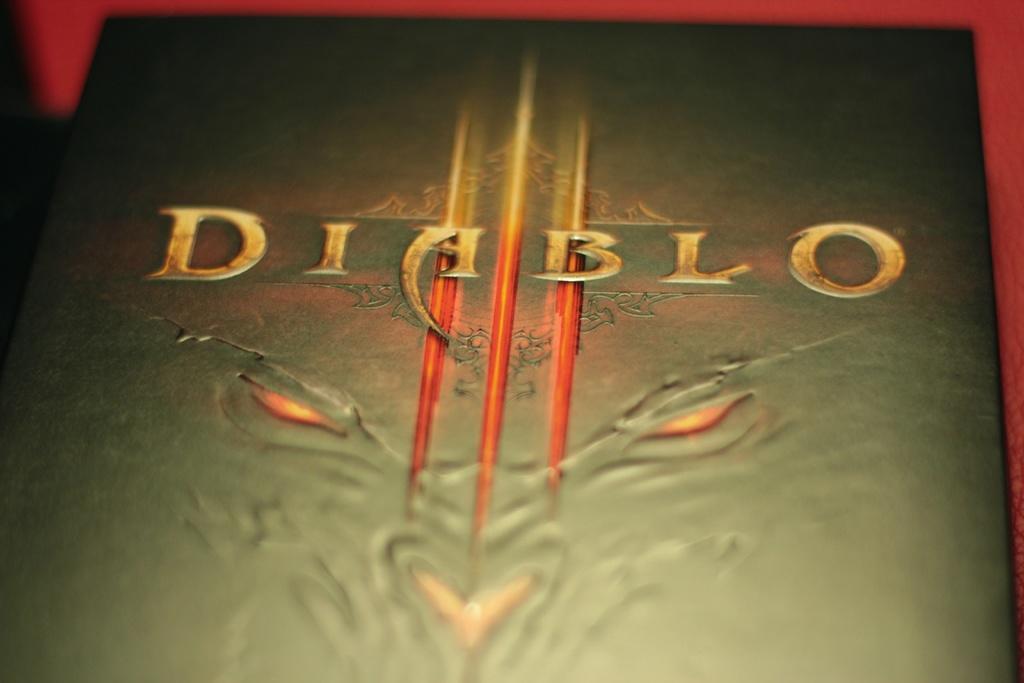How would you summarize this image in a sentence or two? This image consists of a book in black color. The background, is red in color. 